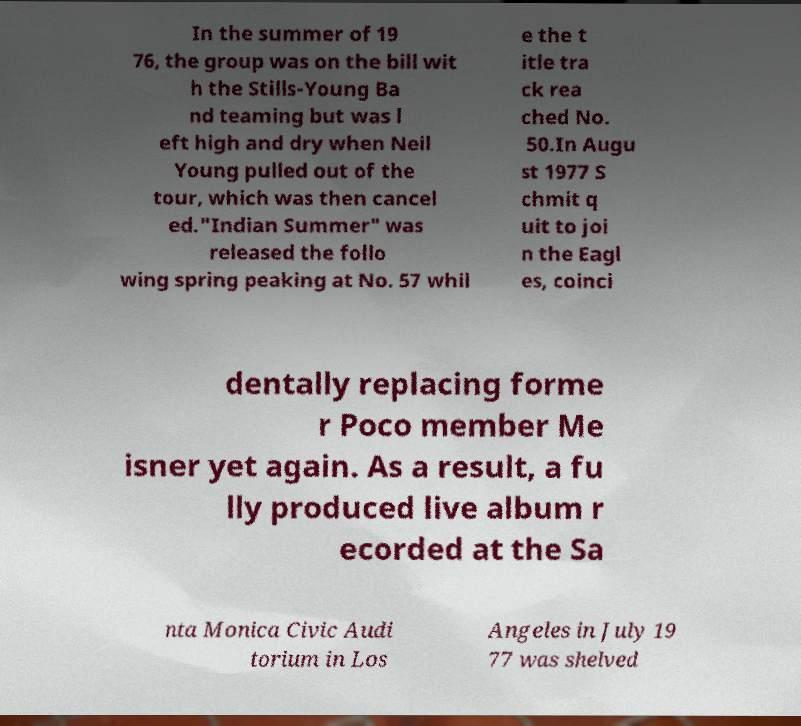There's text embedded in this image that I need extracted. Can you transcribe it verbatim? In the summer of 19 76, the group was on the bill wit h the Stills-Young Ba nd teaming but was l eft high and dry when Neil Young pulled out of the tour, which was then cancel ed."Indian Summer" was released the follo wing spring peaking at No. 57 whil e the t itle tra ck rea ched No. 50.In Augu st 1977 S chmit q uit to joi n the Eagl es, coinci dentally replacing forme r Poco member Me isner yet again. As a result, a fu lly produced live album r ecorded at the Sa nta Monica Civic Audi torium in Los Angeles in July 19 77 was shelved 